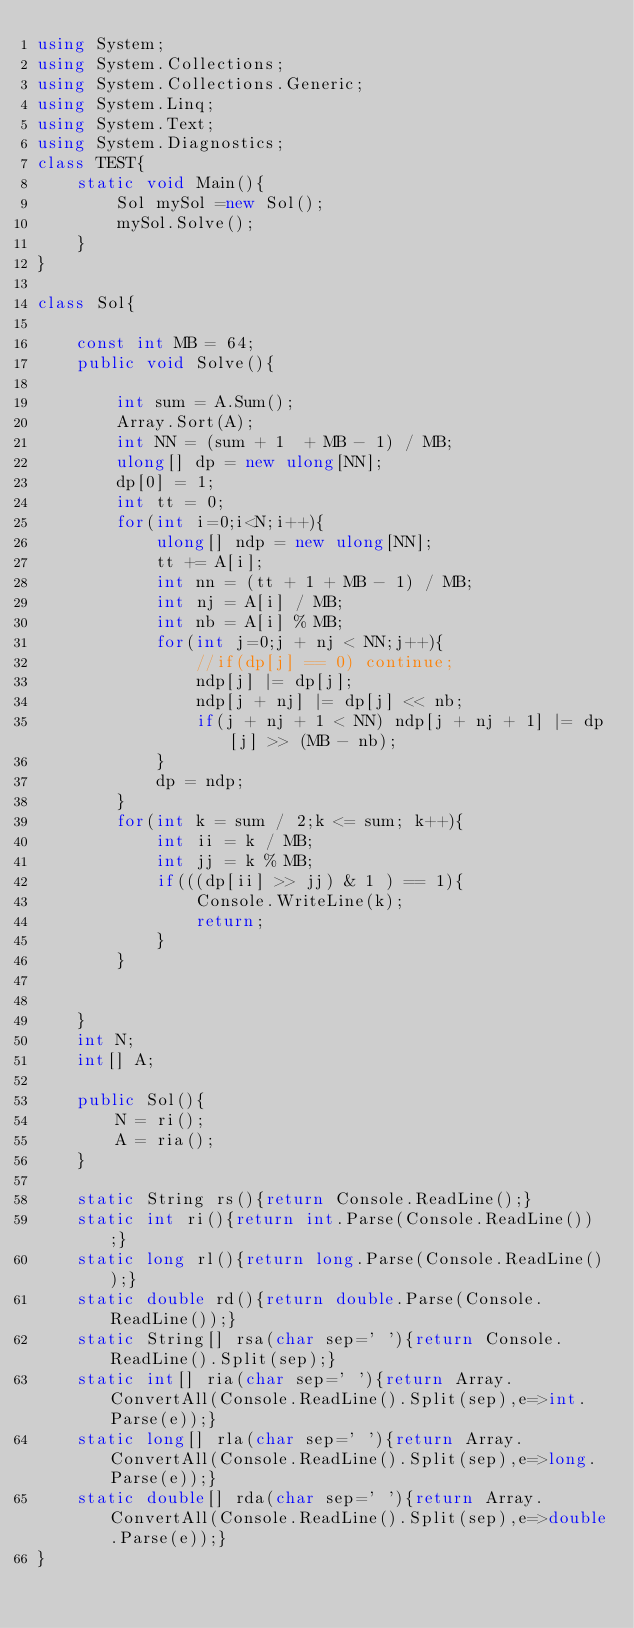Convert code to text. <code><loc_0><loc_0><loc_500><loc_500><_C#_>using System;
using System.Collections;
using System.Collections.Generic;
using System.Linq;
using System.Text;
using System.Diagnostics;
class TEST{
	static void Main(){
		Sol mySol =new Sol();
		mySol.Solve();
	}
}

class Sol{
	
	const int MB = 64;
	public void Solve(){
		
		int sum = A.Sum();
		Array.Sort(A);
		int NN = (sum + 1  + MB - 1) / MB;
		ulong[] dp = new ulong[NN];
		dp[0] = 1;
		int tt = 0;
		for(int i=0;i<N;i++){
			ulong[] ndp = new ulong[NN];
			tt += A[i];
			int nn = (tt + 1 + MB - 1) / MB;
			int nj = A[i] / MB;
			int nb = A[i] % MB;
			for(int j=0;j + nj < NN;j++){
				//if(dp[j] == 0) continue;
				ndp[j] |= dp[j];
				ndp[j + nj] |= dp[j] << nb;
				if(j + nj + 1 < NN) ndp[j + nj + 1] |= dp[j] >> (MB - nb);
			}
			dp = ndp;
		}
		for(int k = sum / 2;k <= sum; k++){
			int ii = k / MB;
			int jj = k % MB;
			if(((dp[ii] >> jj) & 1 ) == 1){
				Console.WriteLine(k);
				return;
			}
		}
		
		
	}
	int N;
	int[] A;

	public Sol(){
		N = ri();
		A = ria();
	}

	static String rs(){return Console.ReadLine();}
	static int ri(){return int.Parse(Console.ReadLine());}
	static long rl(){return long.Parse(Console.ReadLine());}
	static double rd(){return double.Parse(Console.ReadLine());}
	static String[] rsa(char sep=' '){return Console.ReadLine().Split(sep);}
	static int[] ria(char sep=' '){return Array.ConvertAll(Console.ReadLine().Split(sep),e=>int.Parse(e));}
	static long[] rla(char sep=' '){return Array.ConvertAll(Console.ReadLine().Split(sep),e=>long.Parse(e));}
	static double[] rda(char sep=' '){return Array.ConvertAll(Console.ReadLine().Split(sep),e=>double.Parse(e));}
}
</code> 